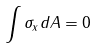<formula> <loc_0><loc_0><loc_500><loc_500>\int \sigma _ { x } d A = 0</formula> 